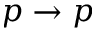<formula> <loc_0><loc_0><loc_500><loc_500>p \rightarrow p</formula> 